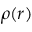<formula> <loc_0><loc_0><loc_500><loc_500>\rho ( r )</formula> 